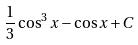<formula> <loc_0><loc_0><loc_500><loc_500>\frac { 1 } { 3 } \cos ^ { 3 } x - \cos x + C</formula> 